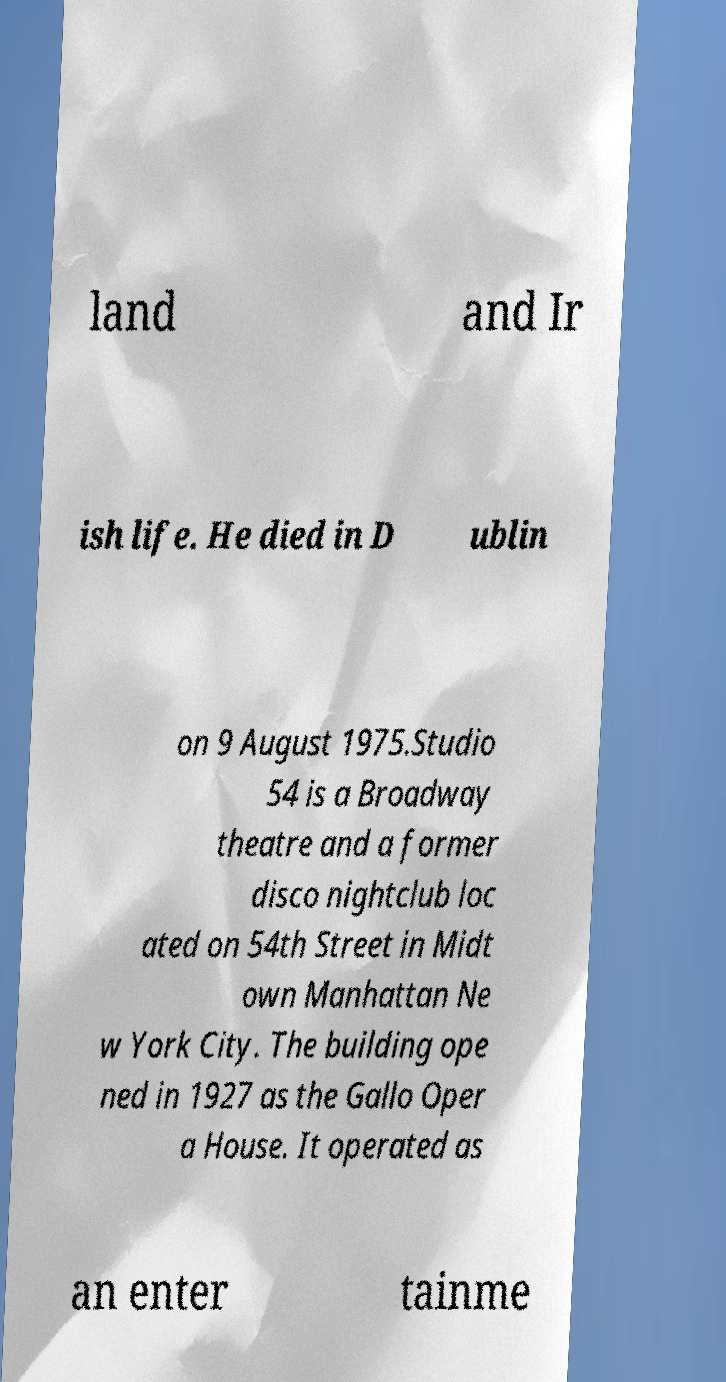For documentation purposes, I need the text within this image transcribed. Could you provide that? land and Ir ish life. He died in D ublin on 9 August 1975.Studio 54 is a Broadway theatre and a former disco nightclub loc ated on 54th Street in Midt own Manhattan Ne w York City. The building ope ned in 1927 as the Gallo Oper a House. It operated as an enter tainme 